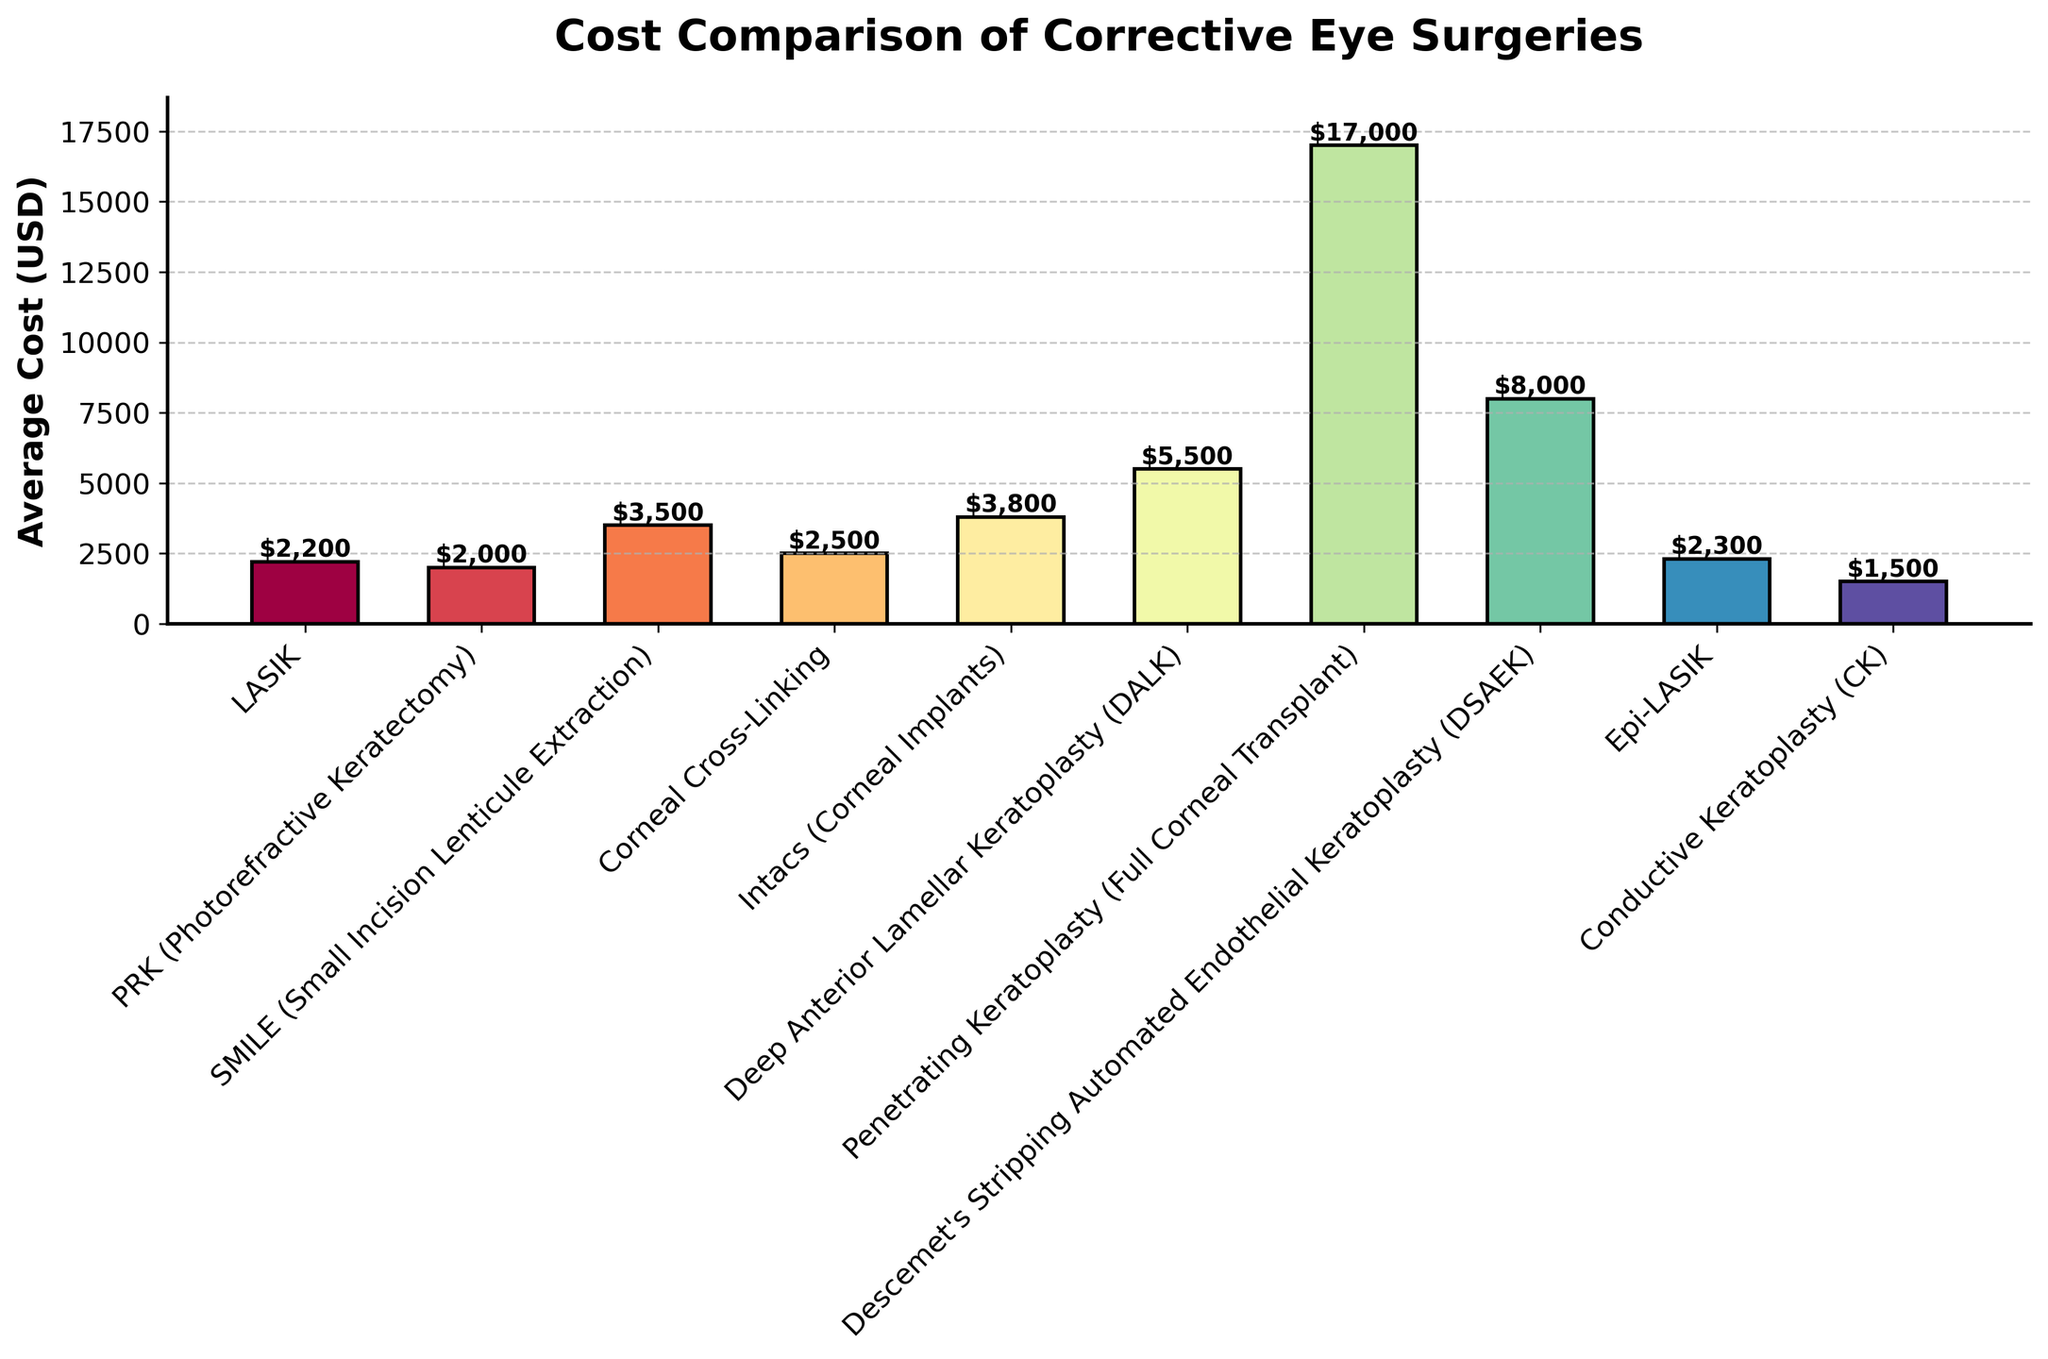What's the most expensive corrective eye surgery shown in the chart? The highest bar in the chart represents the most expensive surgery. By looking at the height of the bars, "Penetrating Keratoplasty (Full Corneal Transplant)" is the tallest, indicating it has the highest cost.
Answer: Penetrating Keratoplasty (Full Corneal Transplant) What's the average cost of LASIK and PRK combined? First, find the costs of LASIK ($2200) and PRK ($2000) from the chart. Add these costs together to get $2200 + $2000 = $4200. Then calculate the average by dividing by 2, yielding $4200 / 2 = $2100.
Answer: $2100 Which surgery is more expensive, SMILE or Corneal Cross-Linking? Identify the bars for SMILE and Corneal Cross-Linking. SMILE has a cost of $3500, while Corneal Cross-Linking has a cost of $2500. Compare these values: $3500 is greater than $2500, so SMILE is more expensive.
Answer: SMILE How much more does Intacs cost compared to Conductive Keratoplasty (CK)? Find the costs of Intacs ($3800) and CK ($1500) from the chart. Then subtract the cost of CK from Intacs: $3800 - $1500 = $2300.
Answer: $2300 What's the average cost of the surgeries that have names starting with the letter 'P'? Identify the surgeries "PRK", "Penetrating Keratoplasty". Their costs are $2000 and $17000 respectively. Calculate the sum: $2000 + $17000 = $19000. Then find the average by dividing by the number of surgeries: $19000 / 2 = $9500.
Answer: $9500 Which surgery types have an average cost above $5000? From the chart, surgeries with costs above $5000 are identified by looking for bars taller than the $5000 mark. These are "Penetrating Keratoplasty" ($17000) and "DSAEK" ($8000).
Answer: Penetrating Keratoplasty (Full Corneal Transplant), DSAEK Compare the costs of Epi-LASIK and LASIK. The chart indicates the cost of Epi-LASIK as $2300 and LASIK as $2200. Comparing these, $2300 is slightly more than $2200.
Answer: Epi-LASIK is more expensive than LASIK How much less does PRK cost compared to DSAEK? The chart gives costs of $2000 for PRK and $8000 for DSAEK. Subtract PRK's cost from DSAEK's: $8000 - $2000 = $6000.
Answer: $6000 Which has a lower average cost, SMILE or DSAEK? The chart indicates a cost of $3500 for SMILE and $8000 for DSAEK. Comparing these costs, $3500 is less than $8000.
Answer: SMILE 